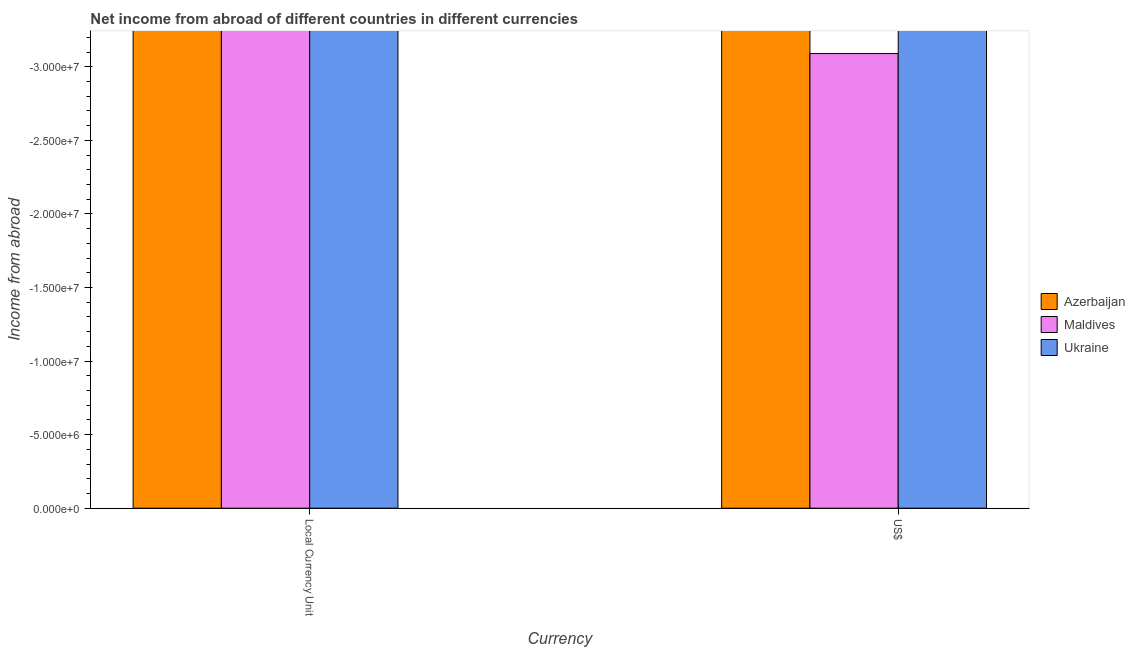Are the number of bars on each tick of the X-axis equal?
Your response must be concise. Yes. How many bars are there on the 2nd tick from the right?
Keep it short and to the point. 0. What is the label of the 2nd group of bars from the left?
Your answer should be compact. US$. Across all countries, what is the minimum income from abroad in constant 2005 us$?
Keep it short and to the point. 0. What is the total income from abroad in constant 2005 us$ in the graph?
Ensure brevity in your answer.  0. What is the difference between the income from abroad in us$ in Ukraine and the income from abroad in constant 2005 us$ in Maldives?
Provide a succinct answer. 0. In how many countries, is the income from abroad in constant 2005 us$ greater than the average income from abroad in constant 2005 us$ taken over all countries?
Offer a terse response. 0. How many countries are there in the graph?
Keep it short and to the point. 3. What is the difference between two consecutive major ticks on the Y-axis?
Keep it short and to the point. 5.00e+06. Are the values on the major ticks of Y-axis written in scientific E-notation?
Provide a succinct answer. Yes. Does the graph contain any zero values?
Keep it short and to the point. Yes. Does the graph contain grids?
Offer a terse response. No. Where does the legend appear in the graph?
Make the answer very short. Center right. How many legend labels are there?
Provide a short and direct response. 3. What is the title of the graph?
Offer a terse response. Net income from abroad of different countries in different currencies. What is the label or title of the X-axis?
Keep it short and to the point. Currency. What is the label or title of the Y-axis?
Ensure brevity in your answer.  Income from abroad. What is the Income from abroad of Azerbaijan in Local Currency Unit?
Provide a succinct answer. 0. What is the Income from abroad of Ukraine in Local Currency Unit?
Your answer should be very brief. 0. What is the Income from abroad in Azerbaijan in US$?
Ensure brevity in your answer.  0. What is the Income from abroad in Ukraine in US$?
Make the answer very short. 0. What is the total Income from abroad in Azerbaijan in the graph?
Ensure brevity in your answer.  0. What is the total Income from abroad of Maldives in the graph?
Your answer should be compact. 0. What is the average Income from abroad of Azerbaijan per Currency?
Your answer should be compact. 0. What is the average Income from abroad in Ukraine per Currency?
Your answer should be very brief. 0. 